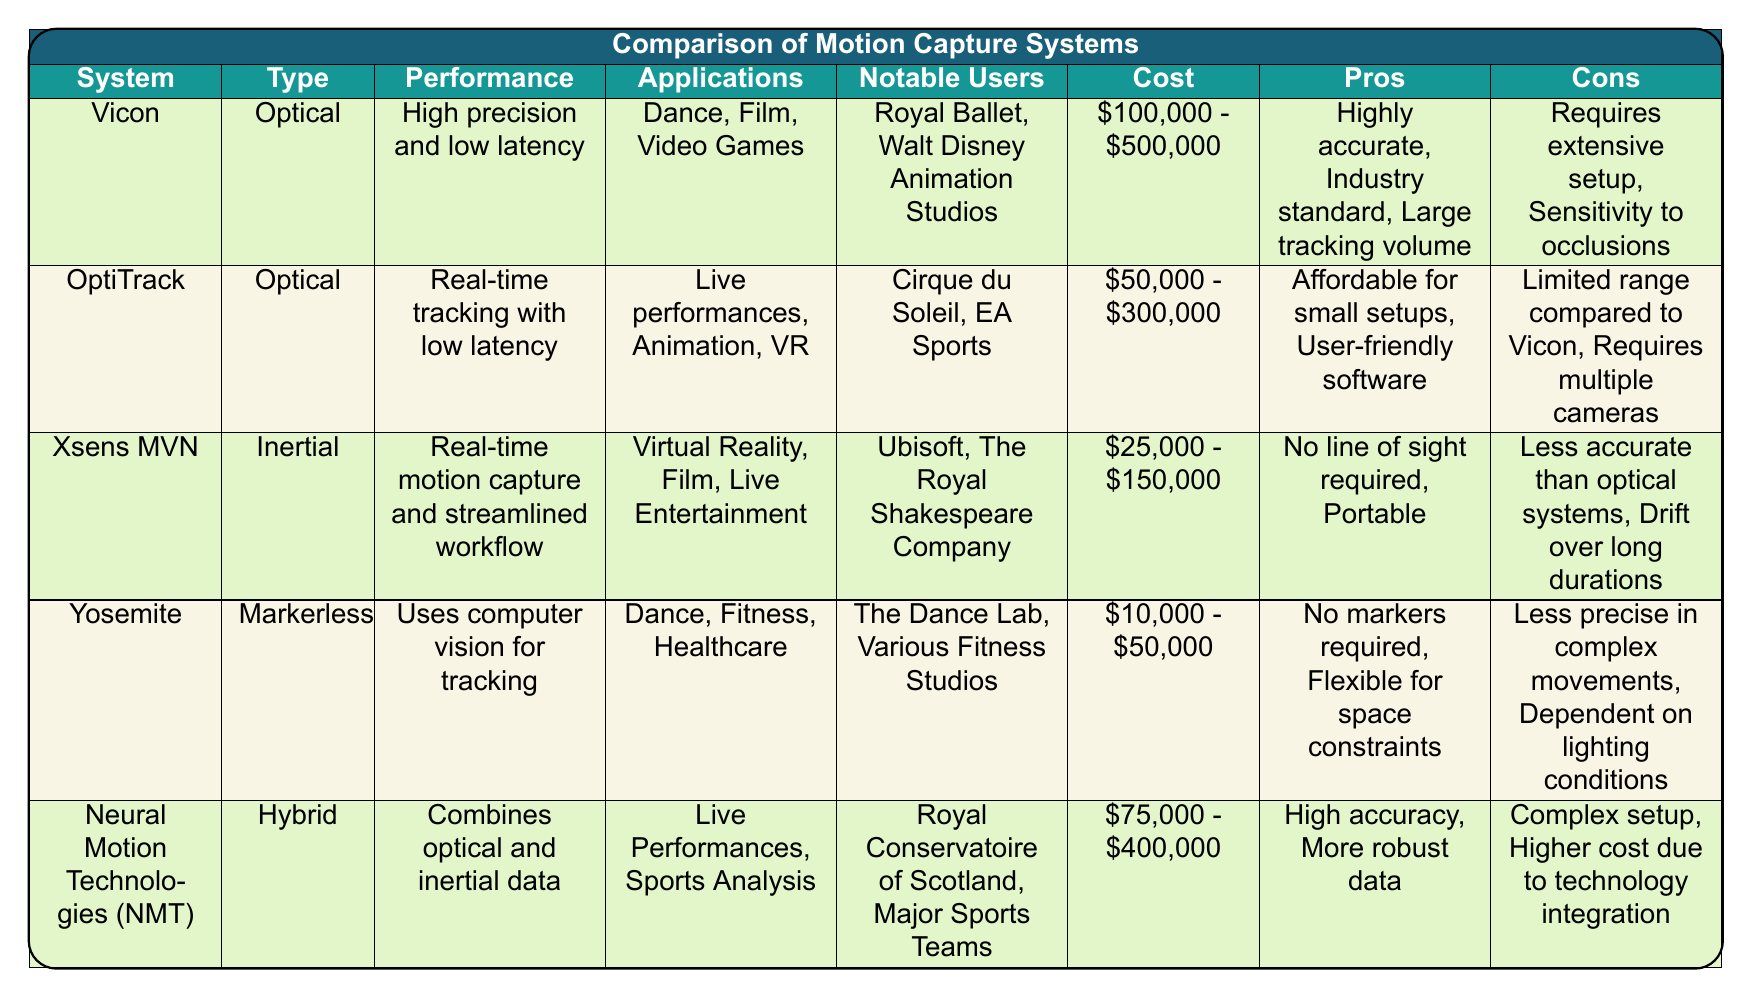What is the cost range of the Vicon motion capture system? The Vicon system's cost is listed in the table as "$100,000 - $500,000."
Answer: $100,000 - $500,000 Which systems are used for live performances? The table shows that OptiTrack and Neural Motion Technologies (NMT) are specifically mentioned for their applications in live performances.
Answer: OptiTrack and NMT Is the Xsens MVN system more affordable than the Yosemite system? The cost range for Xsens MVN is "$25,000 - $150,000" and for Yosemite is "$10,000 - $50,000." Since the maximum for Xsens MVN is higher than Yosemite's maximum, Xsens MVN is not more affordable.
Answer: No What are the pros of the Yosemite motion capture system? The table lists two pros of Yosemite: "No markers required" and "Flexible for space constraints."
Answer: No markers required, Flexible for space constraints Which system has the highest performance rating and what is it? The Vicon system is described as having "High precision and low latency," making it the system with the highest performance rating.
Answer: Vicon, High precision and low latency Are there any systems that require a line of sight for tracking? The Xsens MVN system does not require a line of sight as it is inertial, while Vicon and OptiTrack are optical systems that do require a line of sight. Therefore, there are systems that do require it.
Answer: Yes What is the difference in cost between the most expensive and the least expensive motion capture system? The most expensive system, Vicon, costs up to $500,000, and the least expensive, Yosemite, costs up to $50,000. The difference is $500,000 - $50,000 = $450,000.
Answer: $450,000 Which system uses computer vision for tracking, and what are its notable users? The Yosemite system uses computer vision for tracking, and its notable users include "The Dance Lab" and "Various Fitness Studios."
Answer: Yosemite, The Dance Lab and Various Fitness Studios How many different types of motion capture systems are listed in the table? The table lists four types: Optical, Inertial, Markerless, and Hybrid. Therefore, there are four different types of systems present.
Answer: Four What performance feature is unique to the Xsens MVN compared to other systems? The Xsens MVN claims "Real-time motion capture and streamlined workflow," and does not have the requirement for tracking markers, which differentiates it within the table's context.
Answer: Real-time motion capture and streamlined workflow 